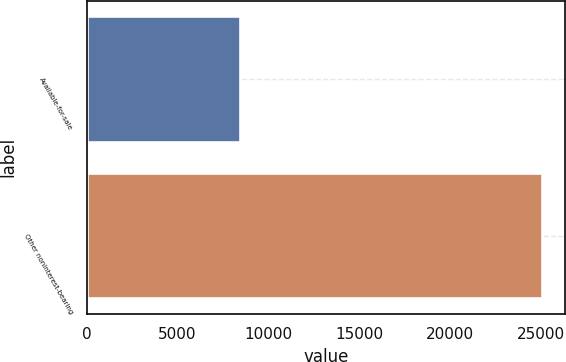<chart> <loc_0><loc_0><loc_500><loc_500><bar_chart><fcel>Available-for-sale<fcel>Other noninterest-bearing<nl><fcel>8443<fcel>25045<nl></chart> 